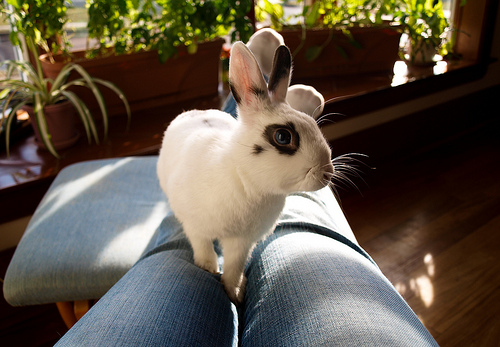<image>
Can you confirm if the rabbit is on the woman? Yes. Looking at the image, I can see the rabbit is positioned on top of the woman, with the woman providing support. Where is the rabbit in relation to the sofa? Is it on the sofa? No. The rabbit is not positioned on the sofa. They may be near each other, but the rabbit is not supported by or resting on top of the sofa. 